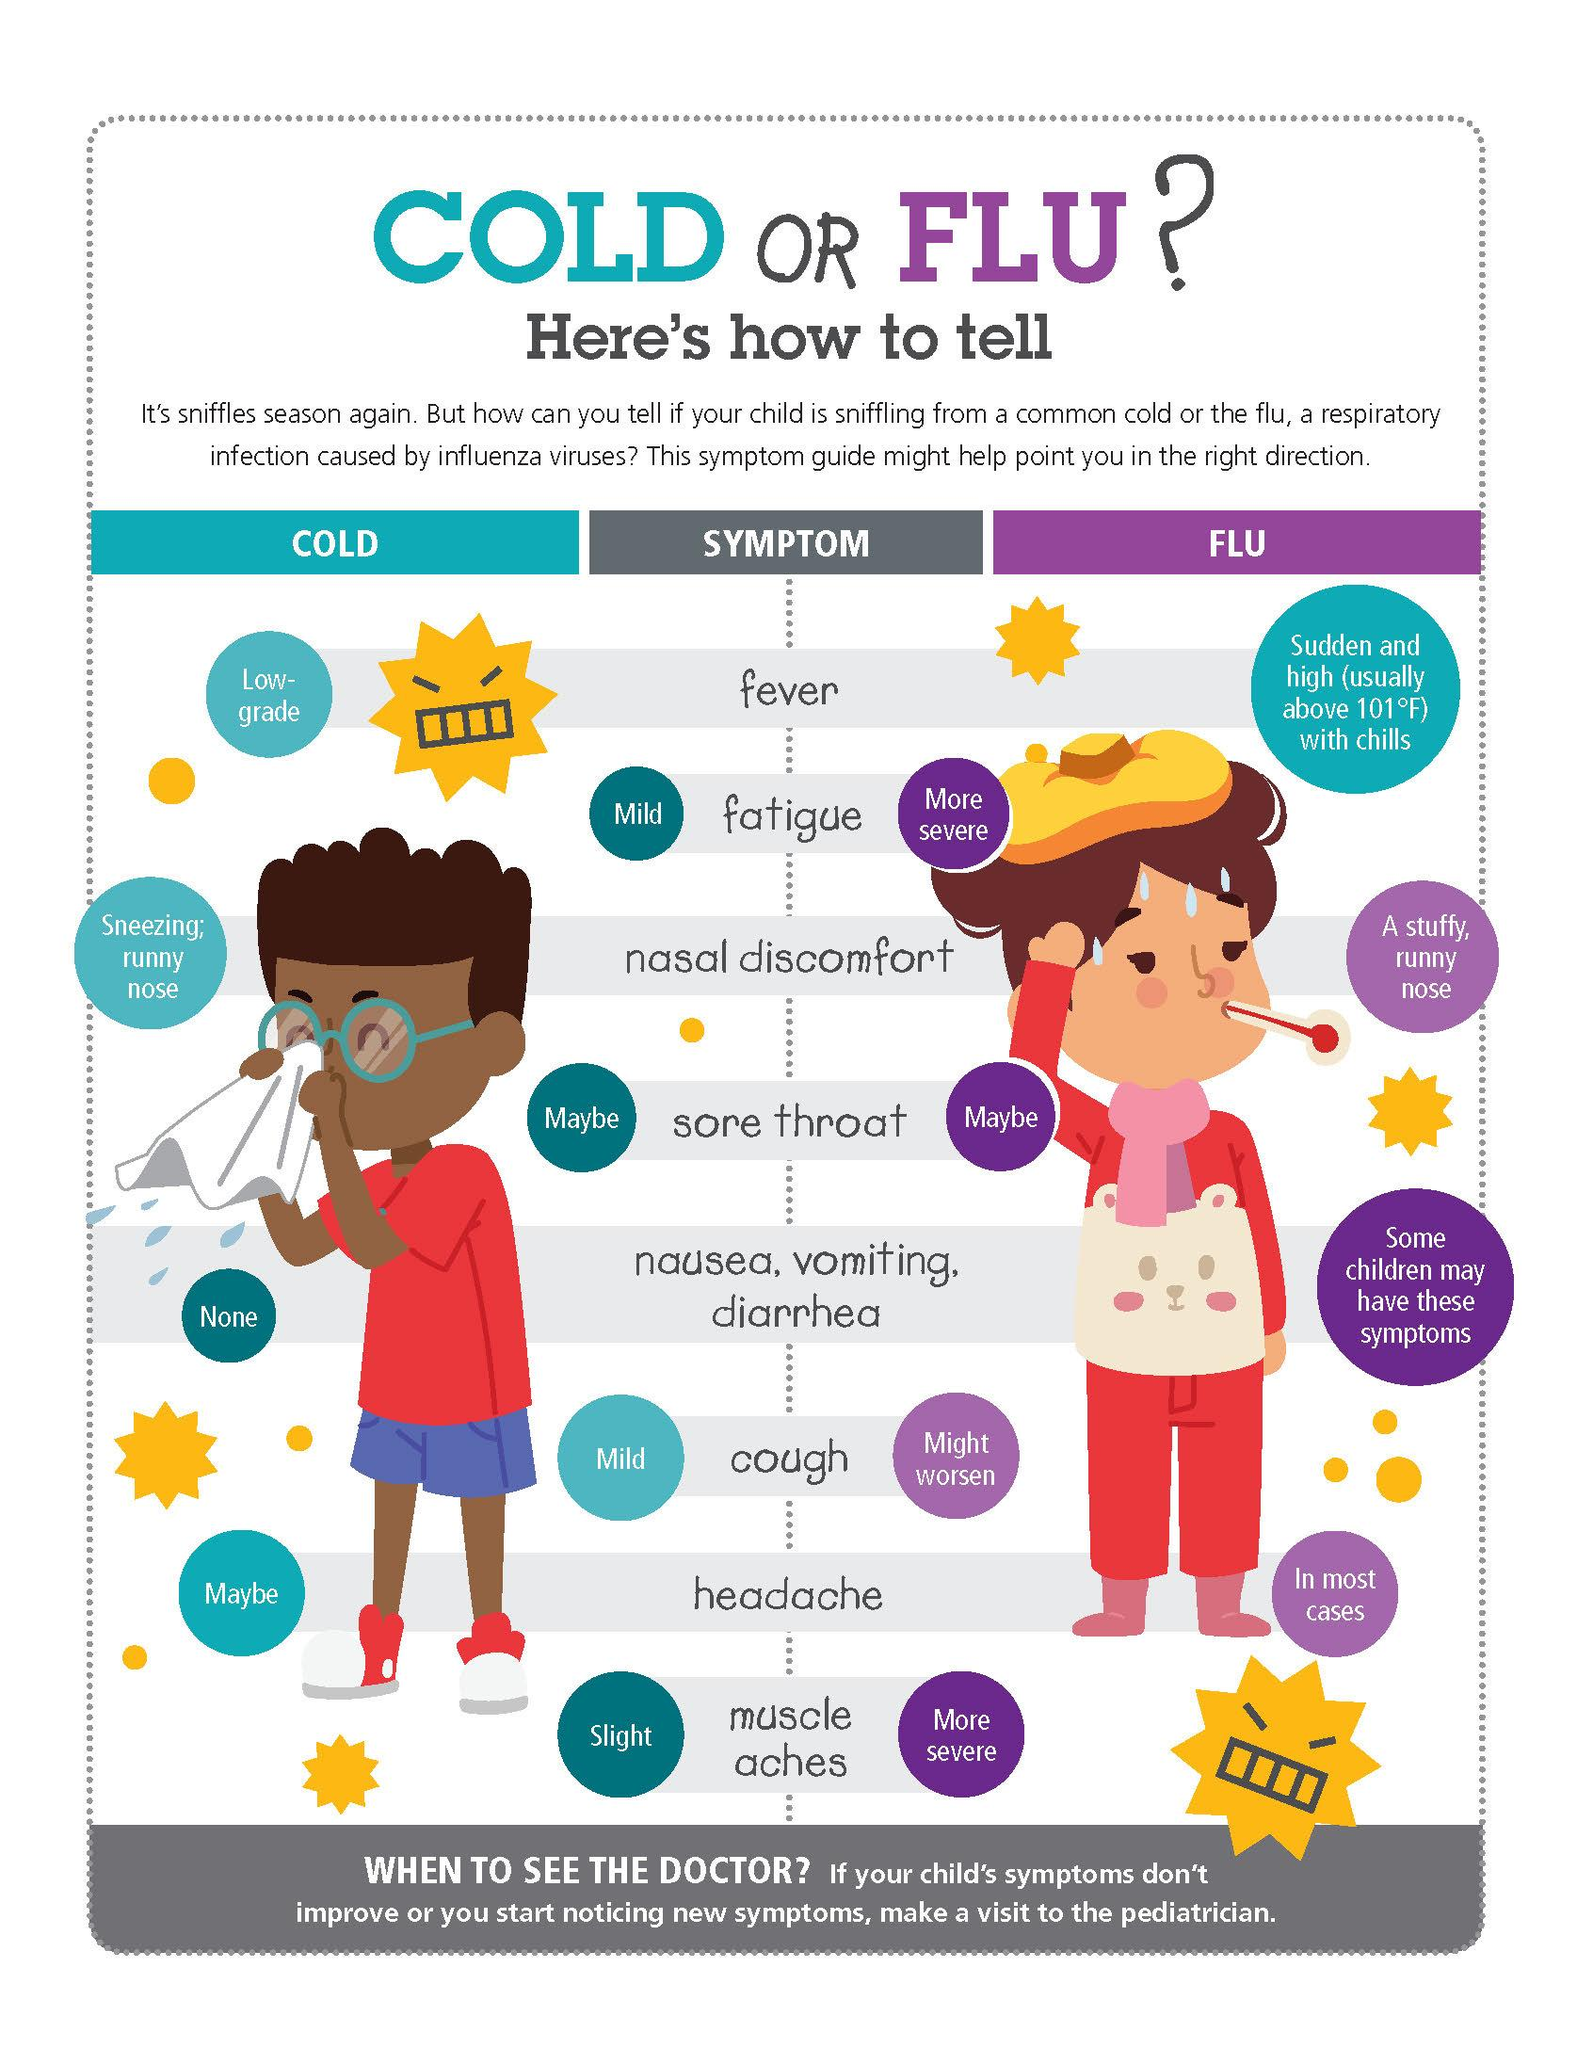Highlight a few significant elements in this photo. There are two mild symptoms associated with the common cold. There are two symptoms of the flu that are more severe than others. The symptoms of flu, specifically fatigue and muscle aches, are more severe than other common flu symptoms. 